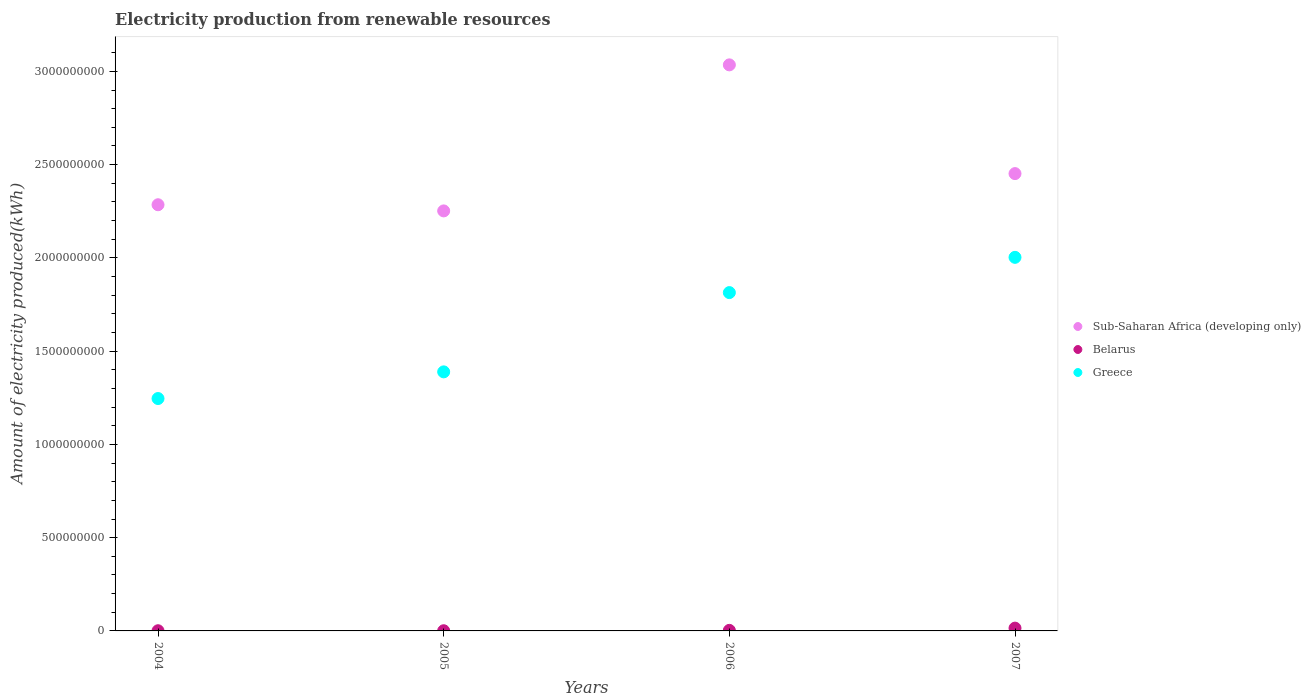Is the number of dotlines equal to the number of legend labels?
Provide a succinct answer. Yes. What is the amount of electricity produced in Sub-Saharan Africa (developing only) in 2007?
Offer a very short reply. 2.45e+09. Across all years, what is the maximum amount of electricity produced in Greece?
Give a very brief answer. 2.00e+09. In which year was the amount of electricity produced in Sub-Saharan Africa (developing only) minimum?
Make the answer very short. 2005. What is the difference between the amount of electricity produced in Sub-Saharan Africa (developing only) in 2004 and that in 2005?
Make the answer very short. 3.30e+07. What is the difference between the amount of electricity produced in Greece in 2004 and the amount of electricity produced in Belarus in 2005?
Your answer should be very brief. 1.24e+09. What is the average amount of electricity produced in Greece per year?
Make the answer very short. 1.61e+09. In the year 2004, what is the difference between the amount of electricity produced in Belarus and amount of electricity produced in Sub-Saharan Africa (developing only)?
Ensure brevity in your answer.  -2.28e+09. What is the ratio of the amount of electricity produced in Sub-Saharan Africa (developing only) in 2005 to that in 2007?
Your answer should be compact. 0.92. Is the amount of electricity produced in Belarus in 2005 less than that in 2007?
Provide a succinct answer. Yes. What is the difference between the highest and the second highest amount of electricity produced in Belarus?
Your response must be concise. 1.20e+07. What is the difference between the highest and the lowest amount of electricity produced in Belarus?
Provide a short and direct response. 1.40e+07. In how many years, is the amount of electricity produced in Greece greater than the average amount of electricity produced in Greece taken over all years?
Offer a very short reply. 2. Is the amount of electricity produced in Sub-Saharan Africa (developing only) strictly greater than the amount of electricity produced in Belarus over the years?
Your answer should be compact. Yes. Is the amount of electricity produced in Belarus strictly less than the amount of electricity produced in Sub-Saharan Africa (developing only) over the years?
Offer a very short reply. Yes. What is the difference between two consecutive major ticks on the Y-axis?
Give a very brief answer. 5.00e+08. Does the graph contain grids?
Your answer should be very brief. No. How many legend labels are there?
Your answer should be compact. 3. How are the legend labels stacked?
Offer a very short reply. Vertical. What is the title of the graph?
Offer a very short reply. Electricity production from renewable resources. What is the label or title of the Y-axis?
Your answer should be very brief. Amount of electricity produced(kWh). What is the Amount of electricity produced(kWh) in Sub-Saharan Africa (developing only) in 2004?
Make the answer very short. 2.28e+09. What is the Amount of electricity produced(kWh) of Greece in 2004?
Keep it short and to the point. 1.25e+09. What is the Amount of electricity produced(kWh) of Sub-Saharan Africa (developing only) in 2005?
Make the answer very short. 2.25e+09. What is the Amount of electricity produced(kWh) of Greece in 2005?
Offer a terse response. 1.39e+09. What is the Amount of electricity produced(kWh) of Sub-Saharan Africa (developing only) in 2006?
Offer a terse response. 3.04e+09. What is the Amount of electricity produced(kWh) of Greece in 2006?
Your response must be concise. 1.81e+09. What is the Amount of electricity produced(kWh) in Sub-Saharan Africa (developing only) in 2007?
Give a very brief answer. 2.45e+09. What is the Amount of electricity produced(kWh) of Belarus in 2007?
Offer a terse response. 1.50e+07. What is the Amount of electricity produced(kWh) of Greece in 2007?
Give a very brief answer. 2.00e+09. Across all years, what is the maximum Amount of electricity produced(kWh) of Sub-Saharan Africa (developing only)?
Provide a short and direct response. 3.04e+09. Across all years, what is the maximum Amount of electricity produced(kWh) in Belarus?
Your response must be concise. 1.50e+07. Across all years, what is the maximum Amount of electricity produced(kWh) in Greece?
Offer a very short reply. 2.00e+09. Across all years, what is the minimum Amount of electricity produced(kWh) in Sub-Saharan Africa (developing only)?
Provide a succinct answer. 2.25e+09. Across all years, what is the minimum Amount of electricity produced(kWh) in Greece?
Give a very brief answer. 1.25e+09. What is the total Amount of electricity produced(kWh) of Sub-Saharan Africa (developing only) in the graph?
Keep it short and to the point. 1.00e+1. What is the total Amount of electricity produced(kWh) in Belarus in the graph?
Provide a succinct answer. 2.00e+07. What is the total Amount of electricity produced(kWh) of Greece in the graph?
Make the answer very short. 6.45e+09. What is the difference between the Amount of electricity produced(kWh) of Sub-Saharan Africa (developing only) in 2004 and that in 2005?
Provide a short and direct response. 3.30e+07. What is the difference between the Amount of electricity produced(kWh) of Greece in 2004 and that in 2005?
Provide a short and direct response. -1.43e+08. What is the difference between the Amount of electricity produced(kWh) of Sub-Saharan Africa (developing only) in 2004 and that in 2006?
Make the answer very short. -7.50e+08. What is the difference between the Amount of electricity produced(kWh) of Greece in 2004 and that in 2006?
Give a very brief answer. -5.68e+08. What is the difference between the Amount of electricity produced(kWh) in Sub-Saharan Africa (developing only) in 2004 and that in 2007?
Ensure brevity in your answer.  -1.67e+08. What is the difference between the Amount of electricity produced(kWh) of Belarus in 2004 and that in 2007?
Give a very brief answer. -1.40e+07. What is the difference between the Amount of electricity produced(kWh) in Greece in 2004 and that in 2007?
Give a very brief answer. -7.57e+08. What is the difference between the Amount of electricity produced(kWh) in Sub-Saharan Africa (developing only) in 2005 and that in 2006?
Offer a terse response. -7.83e+08. What is the difference between the Amount of electricity produced(kWh) in Belarus in 2005 and that in 2006?
Your answer should be compact. -2.00e+06. What is the difference between the Amount of electricity produced(kWh) of Greece in 2005 and that in 2006?
Your answer should be compact. -4.25e+08. What is the difference between the Amount of electricity produced(kWh) of Sub-Saharan Africa (developing only) in 2005 and that in 2007?
Make the answer very short. -2.00e+08. What is the difference between the Amount of electricity produced(kWh) of Belarus in 2005 and that in 2007?
Give a very brief answer. -1.40e+07. What is the difference between the Amount of electricity produced(kWh) in Greece in 2005 and that in 2007?
Provide a succinct answer. -6.14e+08. What is the difference between the Amount of electricity produced(kWh) in Sub-Saharan Africa (developing only) in 2006 and that in 2007?
Give a very brief answer. 5.83e+08. What is the difference between the Amount of electricity produced(kWh) in Belarus in 2006 and that in 2007?
Provide a short and direct response. -1.20e+07. What is the difference between the Amount of electricity produced(kWh) of Greece in 2006 and that in 2007?
Provide a short and direct response. -1.89e+08. What is the difference between the Amount of electricity produced(kWh) in Sub-Saharan Africa (developing only) in 2004 and the Amount of electricity produced(kWh) in Belarus in 2005?
Offer a terse response. 2.28e+09. What is the difference between the Amount of electricity produced(kWh) of Sub-Saharan Africa (developing only) in 2004 and the Amount of electricity produced(kWh) of Greece in 2005?
Offer a very short reply. 8.96e+08. What is the difference between the Amount of electricity produced(kWh) of Belarus in 2004 and the Amount of electricity produced(kWh) of Greece in 2005?
Provide a succinct answer. -1.39e+09. What is the difference between the Amount of electricity produced(kWh) in Sub-Saharan Africa (developing only) in 2004 and the Amount of electricity produced(kWh) in Belarus in 2006?
Ensure brevity in your answer.  2.28e+09. What is the difference between the Amount of electricity produced(kWh) of Sub-Saharan Africa (developing only) in 2004 and the Amount of electricity produced(kWh) of Greece in 2006?
Offer a very short reply. 4.71e+08. What is the difference between the Amount of electricity produced(kWh) in Belarus in 2004 and the Amount of electricity produced(kWh) in Greece in 2006?
Provide a succinct answer. -1.81e+09. What is the difference between the Amount of electricity produced(kWh) in Sub-Saharan Africa (developing only) in 2004 and the Amount of electricity produced(kWh) in Belarus in 2007?
Your response must be concise. 2.27e+09. What is the difference between the Amount of electricity produced(kWh) in Sub-Saharan Africa (developing only) in 2004 and the Amount of electricity produced(kWh) in Greece in 2007?
Your answer should be compact. 2.82e+08. What is the difference between the Amount of electricity produced(kWh) of Belarus in 2004 and the Amount of electricity produced(kWh) of Greece in 2007?
Provide a succinct answer. -2.00e+09. What is the difference between the Amount of electricity produced(kWh) in Sub-Saharan Africa (developing only) in 2005 and the Amount of electricity produced(kWh) in Belarus in 2006?
Offer a terse response. 2.25e+09. What is the difference between the Amount of electricity produced(kWh) of Sub-Saharan Africa (developing only) in 2005 and the Amount of electricity produced(kWh) of Greece in 2006?
Your response must be concise. 4.38e+08. What is the difference between the Amount of electricity produced(kWh) in Belarus in 2005 and the Amount of electricity produced(kWh) in Greece in 2006?
Offer a terse response. -1.81e+09. What is the difference between the Amount of electricity produced(kWh) in Sub-Saharan Africa (developing only) in 2005 and the Amount of electricity produced(kWh) in Belarus in 2007?
Offer a terse response. 2.24e+09. What is the difference between the Amount of electricity produced(kWh) of Sub-Saharan Africa (developing only) in 2005 and the Amount of electricity produced(kWh) of Greece in 2007?
Your answer should be compact. 2.49e+08. What is the difference between the Amount of electricity produced(kWh) in Belarus in 2005 and the Amount of electricity produced(kWh) in Greece in 2007?
Your response must be concise. -2.00e+09. What is the difference between the Amount of electricity produced(kWh) in Sub-Saharan Africa (developing only) in 2006 and the Amount of electricity produced(kWh) in Belarus in 2007?
Offer a terse response. 3.02e+09. What is the difference between the Amount of electricity produced(kWh) of Sub-Saharan Africa (developing only) in 2006 and the Amount of electricity produced(kWh) of Greece in 2007?
Give a very brief answer. 1.03e+09. What is the difference between the Amount of electricity produced(kWh) of Belarus in 2006 and the Amount of electricity produced(kWh) of Greece in 2007?
Your answer should be compact. -2.00e+09. What is the average Amount of electricity produced(kWh) of Sub-Saharan Africa (developing only) per year?
Give a very brief answer. 2.51e+09. What is the average Amount of electricity produced(kWh) of Greece per year?
Ensure brevity in your answer.  1.61e+09. In the year 2004, what is the difference between the Amount of electricity produced(kWh) in Sub-Saharan Africa (developing only) and Amount of electricity produced(kWh) in Belarus?
Provide a short and direct response. 2.28e+09. In the year 2004, what is the difference between the Amount of electricity produced(kWh) of Sub-Saharan Africa (developing only) and Amount of electricity produced(kWh) of Greece?
Give a very brief answer. 1.04e+09. In the year 2004, what is the difference between the Amount of electricity produced(kWh) of Belarus and Amount of electricity produced(kWh) of Greece?
Provide a short and direct response. -1.24e+09. In the year 2005, what is the difference between the Amount of electricity produced(kWh) in Sub-Saharan Africa (developing only) and Amount of electricity produced(kWh) in Belarus?
Your answer should be compact. 2.25e+09. In the year 2005, what is the difference between the Amount of electricity produced(kWh) in Sub-Saharan Africa (developing only) and Amount of electricity produced(kWh) in Greece?
Offer a very short reply. 8.63e+08. In the year 2005, what is the difference between the Amount of electricity produced(kWh) of Belarus and Amount of electricity produced(kWh) of Greece?
Your answer should be very brief. -1.39e+09. In the year 2006, what is the difference between the Amount of electricity produced(kWh) of Sub-Saharan Africa (developing only) and Amount of electricity produced(kWh) of Belarus?
Your answer should be compact. 3.03e+09. In the year 2006, what is the difference between the Amount of electricity produced(kWh) in Sub-Saharan Africa (developing only) and Amount of electricity produced(kWh) in Greece?
Provide a succinct answer. 1.22e+09. In the year 2006, what is the difference between the Amount of electricity produced(kWh) of Belarus and Amount of electricity produced(kWh) of Greece?
Make the answer very short. -1.81e+09. In the year 2007, what is the difference between the Amount of electricity produced(kWh) of Sub-Saharan Africa (developing only) and Amount of electricity produced(kWh) of Belarus?
Your response must be concise. 2.44e+09. In the year 2007, what is the difference between the Amount of electricity produced(kWh) of Sub-Saharan Africa (developing only) and Amount of electricity produced(kWh) of Greece?
Provide a short and direct response. 4.49e+08. In the year 2007, what is the difference between the Amount of electricity produced(kWh) of Belarus and Amount of electricity produced(kWh) of Greece?
Your response must be concise. -1.99e+09. What is the ratio of the Amount of electricity produced(kWh) of Sub-Saharan Africa (developing only) in 2004 to that in 2005?
Offer a very short reply. 1.01. What is the ratio of the Amount of electricity produced(kWh) in Greece in 2004 to that in 2005?
Your response must be concise. 0.9. What is the ratio of the Amount of electricity produced(kWh) of Sub-Saharan Africa (developing only) in 2004 to that in 2006?
Your response must be concise. 0.75. What is the ratio of the Amount of electricity produced(kWh) of Greece in 2004 to that in 2006?
Your response must be concise. 0.69. What is the ratio of the Amount of electricity produced(kWh) of Sub-Saharan Africa (developing only) in 2004 to that in 2007?
Provide a short and direct response. 0.93. What is the ratio of the Amount of electricity produced(kWh) of Belarus in 2004 to that in 2007?
Keep it short and to the point. 0.07. What is the ratio of the Amount of electricity produced(kWh) of Greece in 2004 to that in 2007?
Provide a short and direct response. 0.62. What is the ratio of the Amount of electricity produced(kWh) in Sub-Saharan Africa (developing only) in 2005 to that in 2006?
Ensure brevity in your answer.  0.74. What is the ratio of the Amount of electricity produced(kWh) in Belarus in 2005 to that in 2006?
Your answer should be very brief. 0.33. What is the ratio of the Amount of electricity produced(kWh) in Greece in 2005 to that in 2006?
Make the answer very short. 0.77. What is the ratio of the Amount of electricity produced(kWh) of Sub-Saharan Africa (developing only) in 2005 to that in 2007?
Your response must be concise. 0.92. What is the ratio of the Amount of electricity produced(kWh) in Belarus in 2005 to that in 2007?
Provide a succinct answer. 0.07. What is the ratio of the Amount of electricity produced(kWh) of Greece in 2005 to that in 2007?
Your response must be concise. 0.69. What is the ratio of the Amount of electricity produced(kWh) in Sub-Saharan Africa (developing only) in 2006 to that in 2007?
Your answer should be compact. 1.24. What is the ratio of the Amount of electricity produced(kWh) in Greece in 2006 to that in 2007?
Offer a terse response. 0.91. What is the difference between the highest and the second highest Amount of electricity produced(kWh) in Sub-Saharan Africa (developing only)?
Offer a very short reply. 5.83e+08. What is the difference between the highest and the second highest Amount of electricity produced(kWh) of Greece?
Provide a short and direct response. 1.89e+08. What is the difference between the highest and the lowest Amount of electricity produced(kWh) in Sub-Saharan Africa (developing only)?
Ensure brevity in your answer.  7.83e+08. What is the difference between the highest and the lowest Amount of electricity produced(kWh) of Belarus?
Your answer should be compact. 1.40e+07. What is the difference between the highest and the lowest Amount of electricity produced(kWh) in Greece?
Your answer should be very brief. 7.57e+08. 